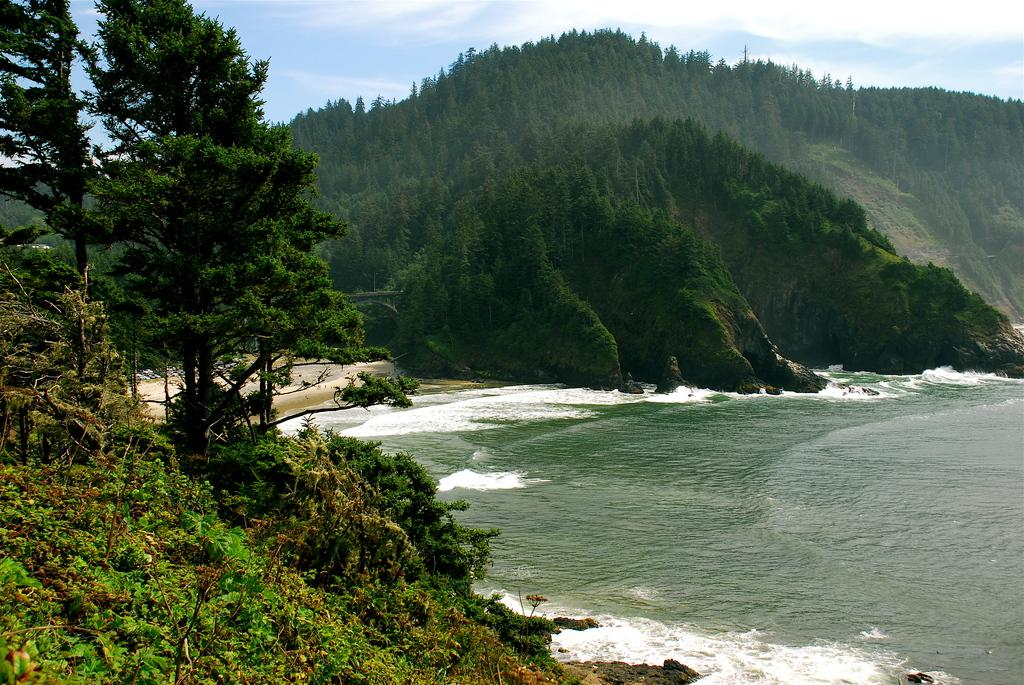What type of vegetation can be seen in the image? There are plants and trees in the image. What natural feature is visible on the right side of the image? The ocean is visible on the right side of the image. What type of landscape can be seen in the background of the image? There are mountains in the background of the image. What is visible at the top of the image? The sky is visible at the top of the image. Where is the lunchroom located in the image? There is no lunchroom present in the image. Can you describe the home that is visible in the image? There is no home present in the image; it features plants, trees, the ocean, mountains, and the sky. 